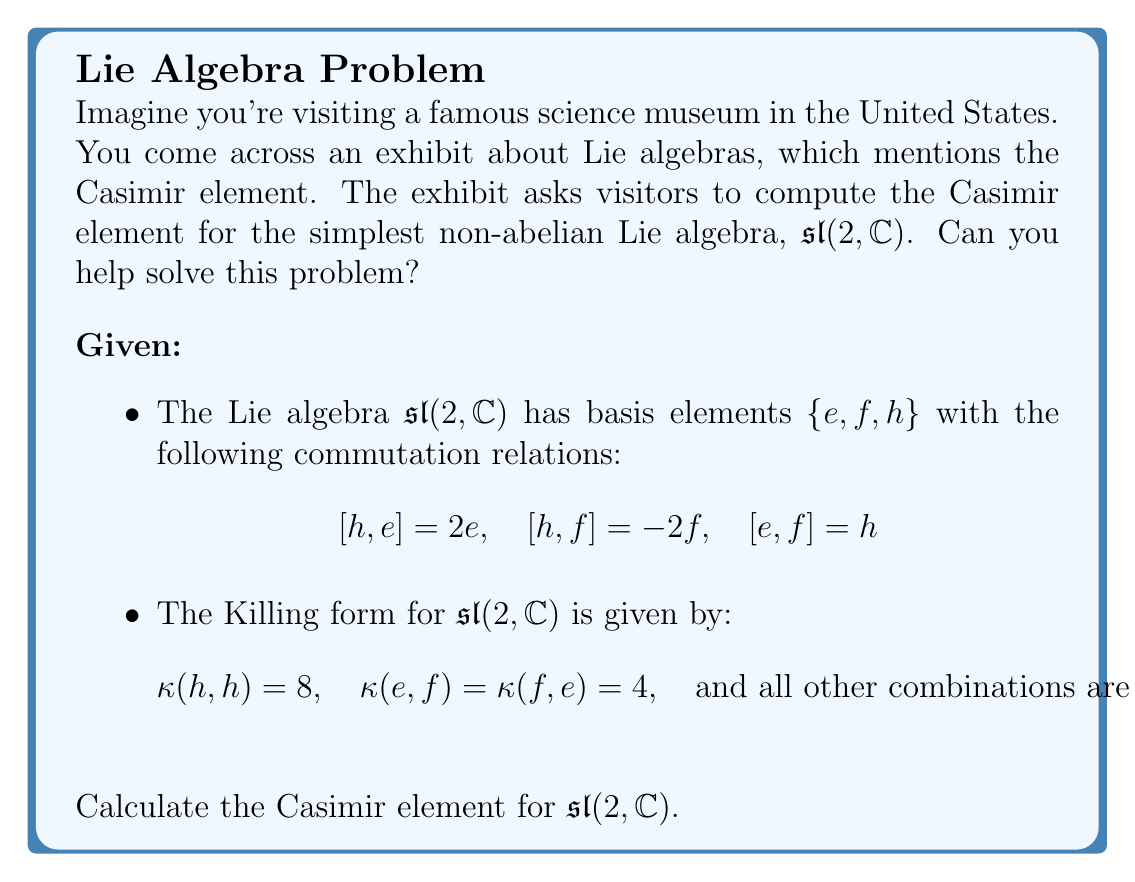Help me with this question. To compute the Casimir element for $\mathfrak{sl}(2,\mathbb{C})$, we'll follow these steps:

1) The Casimir element is defined as $C = \sum_{i,j} \kappa^{ij} x_i x_j$, where $\kappa^{ij}$ are the components of the inverse of the Killing form matrix, and $x_i$ are the basis elements.

2) First, let's write out the Killing form matrix:

   $$\kappa = \begin{pmatrix}
   0 & 4 & 0 \\
   4 & 0 & 0 \\
   0 & 0 & 8
   \end{pmatrix}$$

   where the rows and columns are ordered as $(e, f, h)$.

3) Now, we need to find the inverse of this matrix:

   $$\kappa^{-1} = \frac{1}{32}\begin{pmatrix}
   0 & 8 & 0 \\
   8 & 0 & 0 \\
   0 & 0 & 4
   \end{pmatrix}$$

4) The Casimir element is then:

   $C = \frac{1}{32}(8ef + 8fe + 4h^2)$

5) Since $[e,f] = h$, we can write $fe = ef - h$. Substituting this in:

   $C = \frac{1}{32}(8ef + 8(ef-h) + 4h^2)$
      $= \frac{1}{32}(16ef - 8h + 4h^2)$
      $= \frac{1}{2}ef - \frac{1}{4}h + \frac{1}{8}h^2$

6) This can be rewritten in a more standard form:

   $C = \frac{1}{2}(ef + fe) + \frac{1}{8}h^2$

This is the Casimir element for $\mathfrak{sl}(2,\mathbb{C})$.
Answer: The Casimir element for $\mathfrak{sl}(2,\mathbb{C})$ is:

$$C = \frac{1}{2}(ef + fe) + \frac{1}{8}h^2$$ 